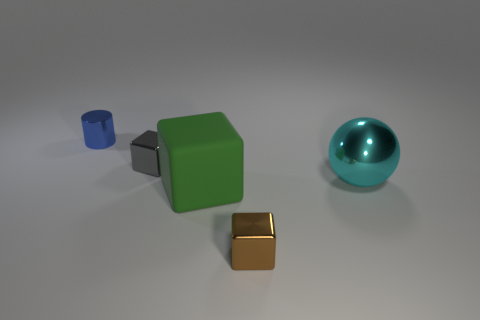There is a metallic thing that is behind the matte thing and in front of the gray metal object; what is its color?
Ensure brevity in your answer.  Cyan. There is a shiny object that is in front of the big cyan object; is its size the same as the metallic cube that is left of the matte block?
Give a very brief answer. Yes. What number of other objects are the same size as the green block?
Provide a short and direct response. 1. How many small brown metallic things are behind the small metal cube that is behind the big sphere?
Offer a terse response. 0. Is the number of matte blocks behind the green thing less than the number of big green blocks?
Ensure brevity in your answer.  Yes. There is a thing behind the metal cube that is left of the metal cube to the right of the gray metal object; what shape is it?
Provide a short and direct response. Cylinder. Is the shape of the gray object the same as the tiny brown metallic thing?
Offer a terse response. Yes. What number of other things are there of the same shape as the big green rubber object?
Offer a terse response. 2. There is a metallic cube that is the same size as the brown thing; what is its color?
Your response must be concise. Gray. Are there an equal number of tiny brown objects to the left of the blue cylinder and small gray metal blocks?
Your response must be concise. No. 